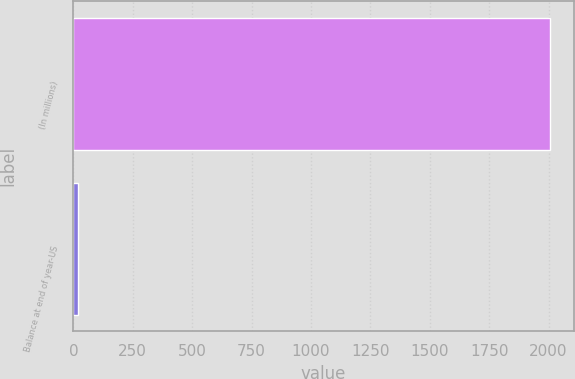Convert chart to OTSL. <chart><loc_0><loc_0><loc_500><loc_500><bar_chart><fcel>(In millions)<fcel>Balance at end of year-US<nl><fcel>2006<fcel>18<nl></chart> 